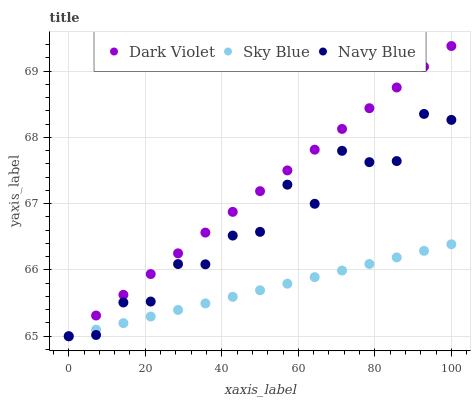Does Sky Blue have the minimum area under the curve?
Answer yes or no. Yes. Does Dark Violet have the maximum area under the curve?
Answer yes or no. Yes. Does Navy Blue have the minimum area under the curve?
Answer yes or no. No. Does Navy Blue have the maximum area under the curve?
Answer yes or no. No. Is Sky Blue the smoothest?
Answer yes or no. Yes. Is Navy Blue the roughest?
Answer yes or no. Yes. Is Dark Violet the smoothest?
Answer yes or no. No. Is Dark Violet the roughest?
Answer yes or no. No. Does Sky Blue have the lowest value?
Answer yes or no. Yes. Does Dark Violet have the highest value?
Answer yes or no. Yes. Does Navy Blue have the highest value?
Answer yes or no. No. Does Sky Blue intersect Dark Violet?
Answer yes or no. Yes. Is Sky Blue less than Dark Violet?
Answer yes or no. No. Is Sky Blue greater than Dark Violet?
Answer yes or no. No. 